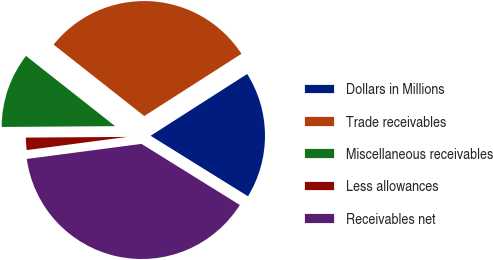Convert chart to OTSL. <chart><loc_0><loc_0><loc_500><loc_500><pie_chart><fcel>Dollars in Millions<fcel>Trade receivables<fcel>Miscellaneous receivables<fcel>Less allowances<fcel>Receivables net<nl><fcel>17.91%<fcel>30.32%<fcel>10.73%<fcel>1.97%<fcel>39.07%<nl></chart> 